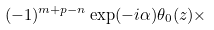<formula> <loc_0><loc_0><loc_500><loc_500>( - 1 ) ^ { m + p - n } \exp ( - i \alpha ) \theta _ { 0 } ( z ) \times</formula> 